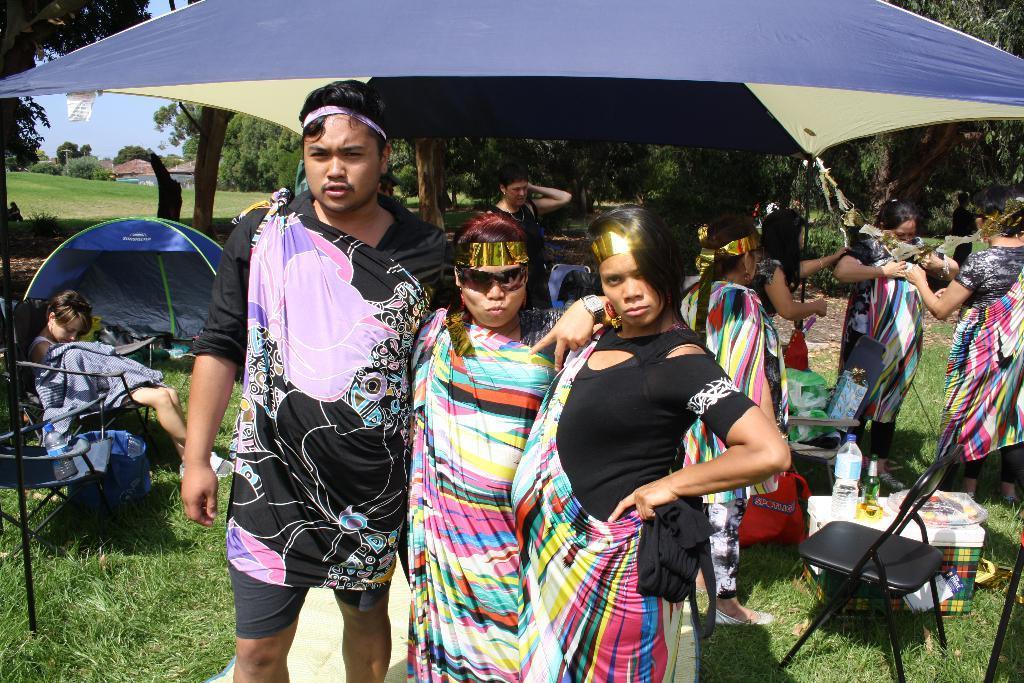Please provide a concise description of this image. In this image I can see three persons wearing black dresses and colorful clothes are standing. In the background I can see few persons standing and a person sitting, few chairs, few bottles, some grass, a tent, few trees, few buildings and the sky. 